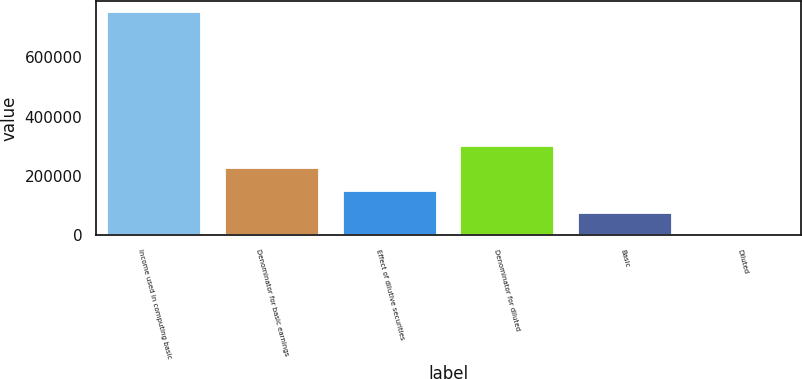Convert chart. <chart><loc_0><loc_0><loc_500><loc_500><bar_chart><fcel>Income used in computing basic<fcel>Denominator for basic earnings<fcel>Effect of dilutive securities<fcel>Denominator for diluted<fcel>Basic<fcel>Diluted<nl><fcel>752207<fcel>225665<fcel>150444<fcel>300885<fcel>75224<fcel>3.69<nl></chart> 